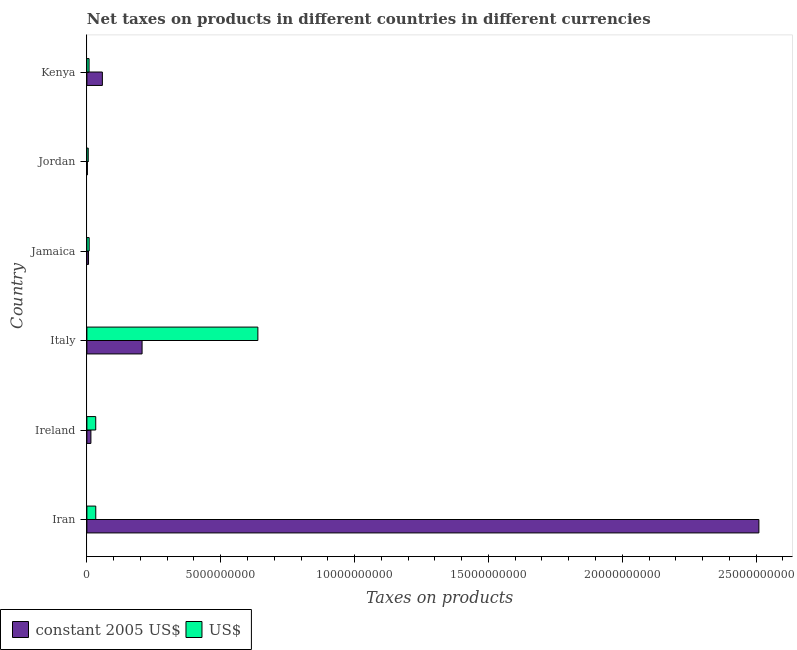How many different coloured bars are there?
Your response must be concise. 2. Are the number of bars on each tick of the Y-axis equal?
Your answer should be compact. Yes. How many bars are there on the 3rd tick from the bottom?
Provide a short and direct response. 2. What is the label of the 5th group of bars from the top?
Provide a succinct answer. Ireland. In how many cases, is the number of bars for a given country not equal to the number of legend labels?
Your response must be concise. 0. What is the net taxes in us$ in Kenya?
Your answer should be very brief. 8.10e+07. Across all countries, what is the maximum net taxes in constant 2005 us$?
Make the answer very short. 2.51e+1. Across all countries, what is the minimum net taxes in constant 2005 us$?
Offer a very short reply. 1.79e+07. In which country was the net taxes in us$ maximum?
Keep it short and to the point. Italy. In which country was the net taxes in constant 2005 us$ minimum?
Your answer should be compact. Jordan. What is the total net taxes in constant 2005 us$ in the graph?
Your response must be concise. 2.80e+1. What is the difference between the net taxes in us$ in Iran and that in Kenya?
Keep it short and to the point. 2.50e+08. What is the difference between the net taxes in us$ in Jamaica and the net taxes in constant 2005 us$ in Jordan?
Offer a very short reply. 6.74e+07. What is the average net taxes in us$ per country?
Your response must be concise. 1.21e+09. What is the difference between the net taxes in us$ and net taxes in constant 2005 us$ in Jordan?
Provide a succinct answer. 3.22e+07. What is the ratio of the net taxes in constant 2005 us$ in Ireland to that in Jamaica?
Your answer should be compact. 2.46. Is the net taxes in constant 2005 us$ in Iran less than that in Ireland?
Provide a succinct answer. No. What is the difference between the highest and the second highest net taxes in us$?
Keep it short and to the point. 6.06e+09. What is the difference between the highest and the lowest net taxes in constant 2005 us$?
Your response must be concise. 2.51e+1. In how many countries, is the net taxes in us$ greater than the average net taxes in us$ taken over all countries?
Provide a short and direct response. 1. What does the 2nd bar from the top in Jamaica represents?
Provide a succinct answer. Constant 2005 us$. What does the 1st bar from the bottom in Jamaica represents?
Your response must be concise. Constant 2005 us$. Are all the bars in the graph horizontal?
Offer a very short reply. Yes. Does the graph contain any zero values?
Give a very brief answer. No. Does the graph contain grids?
Offer a very short reply. No. Where does the legend appear in the graph?
Keep it short and to the point. Bottom left. What is the title of the graph?
Offer a very short reply. Net taxes on products in different countries in different currencies. What is the label or title of the X-axis?
Offer a very short reply. Taxes on products. What is the Taxes on products in constant 2005 US$ in Iran?
Make the answer very short. 2.51e+1. What is the Taxes on products of US$ in Iran?
Provide a succinct answer. 3.31e+08. What is the Taxes on products in constant 2005 US$ in Ireland?
Keep it short and to the point. 1.50e+08. What is the Taxes on products in US$ in Ireland?
Give a very brief answer. 3.30e+08. What is the Taxes on products in constant 2005 US$ in Italy?
Offer a terse response. 2.06e+09. What is the Taxes on products of US$ in Italy?
Make the answer very short. 6.39e+09. What is the Taxes on products in constant 2005 US$ in Jamaica?
Offer a terse response. 6.09e+07. What is the Taxes on products of US$ in Jamaica?
Your response must be concise. 8.53e+07. What is the Taxes on products in constant 2005 US$ in Jordan?
Your answer should be compact. 1.79e+07. What is the Taxes on products of US$ in Jordan?
Keep it short and to the point. 5.01e+07. What is the Taxes on products in constant 2005 US$ in Kenya?
Your response must be concise. 5.78e+08. What is the Taxes on products in US$ in Kenya?
Your answer should be very brief. 8.10e+07. Across all countries, what is the maximum Taxes on products in constant 2005 US$?
Provide a succinct answer. 2.51e+1. Across all countries, what is the maximum Taxes on products in US$?
Provide a succinct answer. 6.39e+09. Across all countries, what is the minimum Taxes on products of constant 2005 US$?
Ensure brevity in your answer.  1.79e+07. Across all countries, what is the minimum Taxes on products in US$?
Make the answer very short. 5.01e+07. What is the total Taxes on products of constant 2005 US$ in the graph?
Make the answer very short. 2.80e+1. What is the total Taxes on products of US$ in the graph?
Give a very brief answer. 7.27e+09. What is the difference between the Taxes on products of constant 2005 US$ in Iran and that in Ireland?
Your response must be concise. 2.50e+1. What is the difference between the Taxes on products in US$ in Iran and that in Ireland?
Provide a short and direct response. 1.32e+06. What is the difference between the Taxes on products of constant 2005 US$ in Iran and that in Italy?
Make the answer very short. 2.30e+1. What is the difference between the Taxes on products in US$ in Iran and that in Italy?
Provide a succinct answer. -6.06e+09. What is the difference between the Taxes on products of constant 2005 US$ in Iran and that in Jamaica?
Make the answer very short. 2.50e+1. What is the difference between the Taxes on products in US$ in Iran and that in Jamaica?
Provide a short and direct response. 2.46e+08. What is the difference between the Taxes on products in constant 2005 US$ in Iran and that in Jordan?
Offer a terse response. 2.51e+1. What is the difference between the Taxes on products of US$ in Iran and that in Jordan?
Ensure brevity in your answer.  2.81e+08. What is the difference between the Taxes on products of constant 2005 US$ in Iran and that in Kenya?
Make the answer very short. 2.45e+1. What is the difference between the Taxes on products in US$ in Iran and that in Kenya?
Ensure brevity in your answer.  2.50e+08. What is the difference between the Taxes on products of constant 2005 US$ in Ireland and that in Italy?
Offer a very short reply. -1.91e+09. What is the difference between the Taxes on products in US$ in Ireland and that in Italy?
Ensure brevity in your answer.  -6.06e+09. What is the difference between the Taxes on products of constant 2005 US$ in Ireland and that in Jamaica?
Provide a succinct answer. 8.88e+07. What is the difference between the Taxes on products in US$ in Ireland and that in Jamaica?
Make the answer very short. 2.45e+08. What is the difference between the Taxes on products in constant 2005 US$ in Ireland and that in Jordan?
Your response must be concise. 1.32e+08. What is the difference between the Taxes on products of US$ in Ireland and that in Jordan?
Your response must be concise. 2.80e+08. What is the difference between the Taxes on products of constant 2005 US$ in Ireland and that in Kenya?
Make the answer very short. -4.29e+08. What is the difference between the Taxes on products of US$ in Ireland and that in Kenya?
Your answer should be compact. 2.49e+08. What is the difference between the Taxes on products in constant 2005 US$ in Italy and that in Jamaica?
Your answer should be very brief. 2.00e+09. What is the difference between the Taxes on products of US$ in Italy and that in Jamaica?
Ensure brevity in your answer.  6.30e+09. What is the difference between the Taxes on products in constant 2005 US$ in Italy and that in Jordan?
Ensure brevity in your answer.  2.04e+09. What is the difference between the Taxes on products in US$ in Italy and that in Jordan?
Offer a very short reply. 6.34e+09. What is the difference between the Taxes on products of constant 2005 US$ in Italy and that in Kenya?
Offer a very short reply. 1.48e+09. What is the difference between the Taxes on products of US$ in Italy and that in Kenya?
Provide a succinct answer. 6.31e+09. What is the difference between the Taxes on products in constant 2005 US$ in Jamaica and that in Jordan?
Your answer should be very brief. 4.30e+07. What is the difference between the Taxes on products in US$ in Jamaica and that in Jordan?
Make the answer very short. 3.51e+07. What is the difference between the Taxes on products in constant 2005 US$ in Jamaica and that in Kenya?
Offer a very short reply. -5.18e+08. What is the difference between the Taxes on products of US$ in Jamaica and that in Kenya?
Ensure brevity in your answer.  4.28e+06. What is the difference between the Taxes on products of constant 2005 US$ in Jordan and that in Kenya?
Offer a very short reply. -5.60e+08. What is the difference between the Taxes on products in US$ in Jordan and that in Kenya?
Provide a succinct answer. -3.09e+07. What is the difference between the Taxes on products in constant 2005 US$ in Iran and the Taxes on products in US$ in Ireland?
Ensure brevity in your answer.  2.48e+1. What is the difference between the Taxes on products in constant 2005 US$ in Iran and the Taxes on products in US$ in Italy?
Keep it short and to the point. 1.87e+1. What is the difference between the Taxes on products of constant 2005 US$ in Iran and the Taxes on products of US$ in Jamaica?
Give a very brief answer. 2.50e+1. What is the difference between the Taxes on products of constant 2005 US$ in Iran and the Taxes on products of US$ in Jordan?
Give a very brief answer. 2.51e+1. What is the difference between the Taxes on products in constant 2005 US$ in Iran and the Taxes on products in US$ in Kenya?
Your answer should be very brief. 2.50e+1. What is the difference between the Taxes on products of constant 2005 US$ in Ireland and the Taxes on products of US$ in Italy?
Ensure brevity in your answer.  -6.24e+09. What is the difference between the Taxes on products in constant 2005 US$ in Ireland and the Taxes on products in US$ in Jamaica?
Your response must be concise. 6.44e+07. What is the difference between the Taxes on products in constant 2005 US$ in Ireland and the Taxes on products in US$ in Jordan?
Your answer should be compact. 9.96e+07. What is the difference between the Taxes on products of constant 2005 US$ in Ireland and the Taxes on products of US$ in Kenya?
Provide a short and direct response. 6.87e+07. What is the difference between the Taxes on products of constant 2005 US$ in Italy and the Taxes on products of US$ in Jamaica?
Keep it short and to the point. 1.98e+09. What is the difference between the Taxes on products of constant 2005 US$ in Italy and the Taxes on products of US$ in Jordan?
Keep it short and to the point. 2.01e+09. What is the difference between the Taxes on products in constant 2005 US$ in Italy and the Taxes on products in US$ in Kenya?
Your answer should be very brief. 1.98e+09. What is the difference between the Taxes on products of constant 2005 US$ in Jamaica and the Taxes on products of US$ in Jordan?
Keep it short and to the point. 1.08e+07. What is the difference between the Taxes on products in constant 2005 US$ in Jamaica and the Taxes on products in US$ in Kenya?
Your answer should be compact. -2.01e+07. What is the difference between the Taxes on products of constant 2005 US$ in Jordan and the Taxes on products of US$ in Kenya?
Your answer should be compact. -6.31e+07. What is the average Taxes on products in constant 2005 US$ per country?
Give a very brief answer. 4.66e+09. What is the average Taxes on products of US$ per country?
Your response must be concise. 1.21e+09. What is the difference between the Taxes on products of constant 2005 US$ and Taxes on products of US$ in Iran?
Offer a very short reply. 2.48e+1. What is the difference between the Taxes on products in constant 2005 US$ and Taxes on products in US$ in Ireland?
Provide a succinct answer. -1.80e+08. What is the difference between the Taxes on products of constant 2005 US$ and Taxes on products of US$ in Italy?
Ensure brevity in your answer.  -4.33e+09. What is the difference between the Taxes on products in constant 2005 US$ and Taxes on products in US$ in Jamaica?
Offer a very short reply. -2.44e+07. What is the difference between the Taxes on products in constant 2005 US$ and Taxes on products in US$ in Jordan?
Provide a succinct answer. -3.22e+07. What is the difference between the Taxes on products of constant 2005 US$ and Taxes on products of US$ in Kenya?
Offer a terse response. 4.97e+08. What is the ratio of the Taxes on products of constant 2005 US$ in Iran to that in Ireland?
Ensure brevity in your answer.  167.71. What is the ratio of the Taxes on products in US$ in Iran to that in Ireland?
Ensure brevity in your answer.  1. What is the ratio of the Taxes on products in constant 2005 US$ in Iran to that in Italy?
Provide a short and direct response. 12.18. What is the ratio of the Taxes on products of US$ in Iran to that in Italy?
Your answer should be compact. 0.05. What is the ratio of the Taxes on products of constant 2005 US$ in Iran to that in Jamaica?
Give a very brief answer. 412.21. What is the ratio of the Taxes on products of US$ in Iran to that in Jamaica?
Give a very brief answer. 3.89. What is the ratio of the Taxes on products of constant 2005 US$ in Iran to that in Jordan?
Your response must be concise. 1402.44. What is the ratio of the Taxes on products in US$ in Iran to that in Jordan?
Your response must be concise. 6.61. What is the ratio of the Taxes on products of constant 2005 US$ in Iran to that in Kenya?
Provide a short and direct response. 43.4. What is the ratio of the Taxes on products of US$ in Iran to that in Kenya?
Give a very brief answer. 4.09. What is the ratio of the Taxes on products in constant 2005 US$ in Ireland to that in Italy?
Your answer should be compact. 0.07. What is the ratio of the Taxes on products in US$ in Ireland to that in Italy?
Ensure brevity in your answer.  0.05. What is the ratio of the Taxes on products of constant 2005 US$ in Ireland to that in Jamaica?
Ensure brevity in your answer.  2.46. What is the ratio of the Taxes on products of US$ in Ireland to that in Jamaica?
Give a very brief answer. 3.87. What is the ratio of the Taxes on products of constant 2005 US$ in Ireland to that in Jordan?
Ensure brevity in your answer.  8.36. What is the ratio of the Taxes on products in US$ in Ireland to that in Jordan?
Give a very brief answer. 6.59. What is the ratio of the Taxes on products of constant 2005 US$ in Ireland to that in Kenya?
Provide a short and direct response. 0.26. What is the ratio of the Taxes on products of US$ in Ireland to that in Kenya?
Your answer should be very brief. 4.08. What is the ratio of the Taxes on products of constant 2005 US$ in Italy to that in Jamaica?
Offer a terse response. 33.85. What is the ratio of the Taxes on products of US$ in Italy to that in Jamaica?
Provide a short and direct response. 74.91. What is the ratio of the Taxes on products of constant 2005 US$ in Italy to that in Jordan?
Offer a very short reply. 115.18. What is the ratio of the Taxes on products of US$ in Italy to that in Jordan?
Offer a very short reply. 127.44. What is the ratio of the Taxes on products in constant 2005 US$ in Italy to that in Kenya?
Provide a succinct answer. 3.56. What is the ratio of the Taxes on products of US$ in Italy to that in Kenya?
Make the answer very short. 78.88. What is the ratio of the Taxes on products in constant 2005 US$ in Jamaica to that in Jordan?
Offer a very short reply. 3.4. What is the ratio of the Taxes on products of US$ in Jamaica to that in Jordan?
Your answer should be very brief. 1.7. What is the ratio of the Taxes on products of constant 2005 US$ in Jamaica to that in Kenya?
Ensure brevity in your answer.  0.11. What is the ratio of the Taxes on products of US$ in Jamaica to that in Kenya?
Provide a short and direct response. 1.05. What is the ratio of the Taxes on products of constant 2005 US$ in Jordan to that in Kenya?
Provide a short and direct response. 0.03. What is the ratio of the Taxes on products of US$ in Jordan to that in Kenya?
Ensure brevity in your answer.  0.62. What is the difference between the highest and the second highest Taxes on products in constant 2005 US$?
Give a very brief answer. 2.30e+1. What is the difference between the highest and the second highest Taxes on products of US$?
Offer a very short reply. 6.06e+09. What is the difference between the highest and the lowest Taxes on products of constant 2005 US$?
Keep it short and to the point. 2.51e+1. What is the difference between the highest and the lowest Taxes on products of US$?
Offer a very short reply. 6.34e+09. 